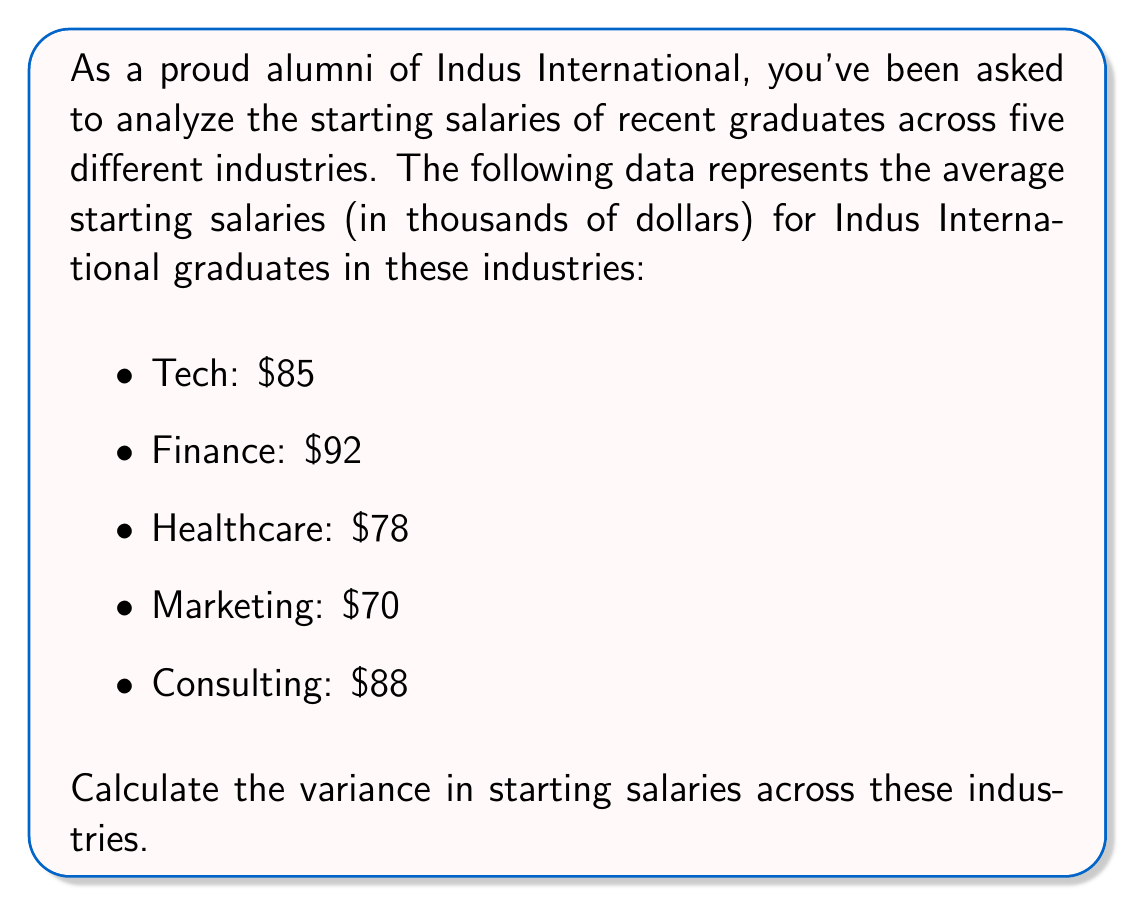Can you solve this math problem? To calculate the variance, we'll follow these steps:

1. Calculate the mean (average) salary:
   $\mu = \frac{85 + 92 + 78 + 70 + 88}{5} = \frac{413}{5} = 82.6$ thousand dollars

2. Calculate the squared differences from the mean:
   Tech: $(85 - 82.6)^2 = 2.4^2 = 5.76$
   Finance: $(92 - 82.6)^2 = 9.4^2 = 88.36$
   Healthcare: $(78 - 82.6)^2 = (-4.6)^2 = 21.16$
   Marketing: $(70 - 82.6)^2 = (-12.6)^2 = 158.76$
   Consulting: $(88 - 82.6)^2 = 5.4^2 = 29.16$

3. Calculate the average of these squared differences:
   Variance = $\frac{5.76 + 88.36 + 21.16 + 158.76 + 29.16}{5}$
             $= \frac{303.2}{5}$
             $= 60.64$

Therefore, the variance in starting salaries is $60.64$ (thousand dollars squared).
Answer: $$60.64 \text{ (thousand dollars}^2)$$ 